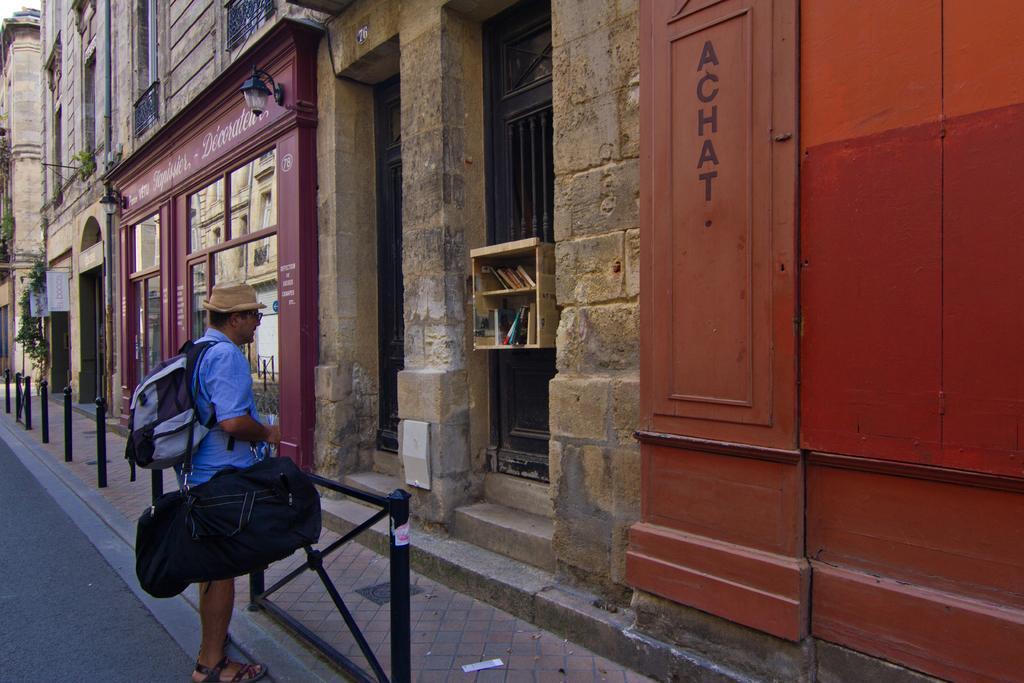Describe this image in one or two sentences. In this picture, we see a man in the blue shirt is standing and he is wearing a backpack, black color bag and a hat. In front of him, we see the poles. Beside him, we see the black color poles. Beside the poles, we see the stairs. In the middle, we see the buildings. On the right side, we see a wall in brown color. Beside that, we see a small rack in which the books and a blue color objects are placed. There are trees and the white color boards on the left side. At the bottom, we see the road. 